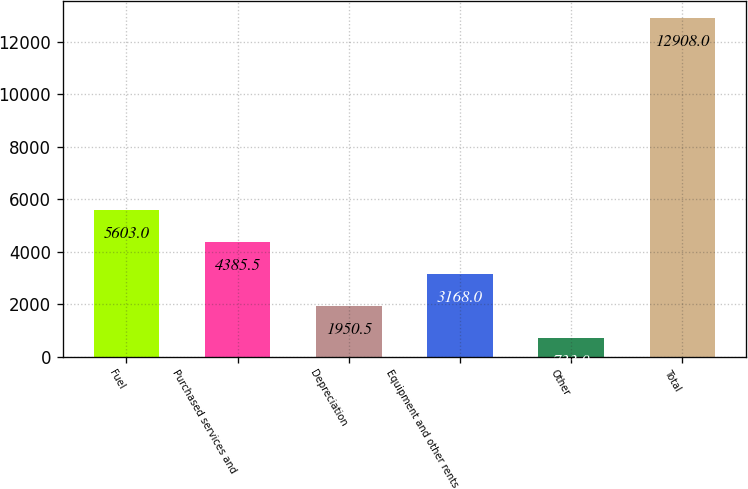Convert chart. <chart><loc_0><loc_0><loc_500><loc_500><bar_chart><fcel>Fuel<fcel>Purchased services and<fcel>Depreciation<fcel>Equipment and other rents<fcel>Other<fcel>Total<nl><fcel>5603<fcel>4385.5<fcel>1950.5<fcel>3168<fcel>733<fcel>12908<nl></chart> 